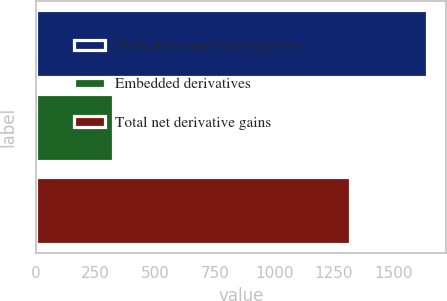Convert chart. <chart><loc_0><loc_0><loc_500><loc_500><bar_chart><fcel>Derivatives and hedging gains<fcel>Embedded derivatives<fcel>Total net derivative gains<nl><fcel>1638<fcel>321<fcel>1317<nl></chart> 